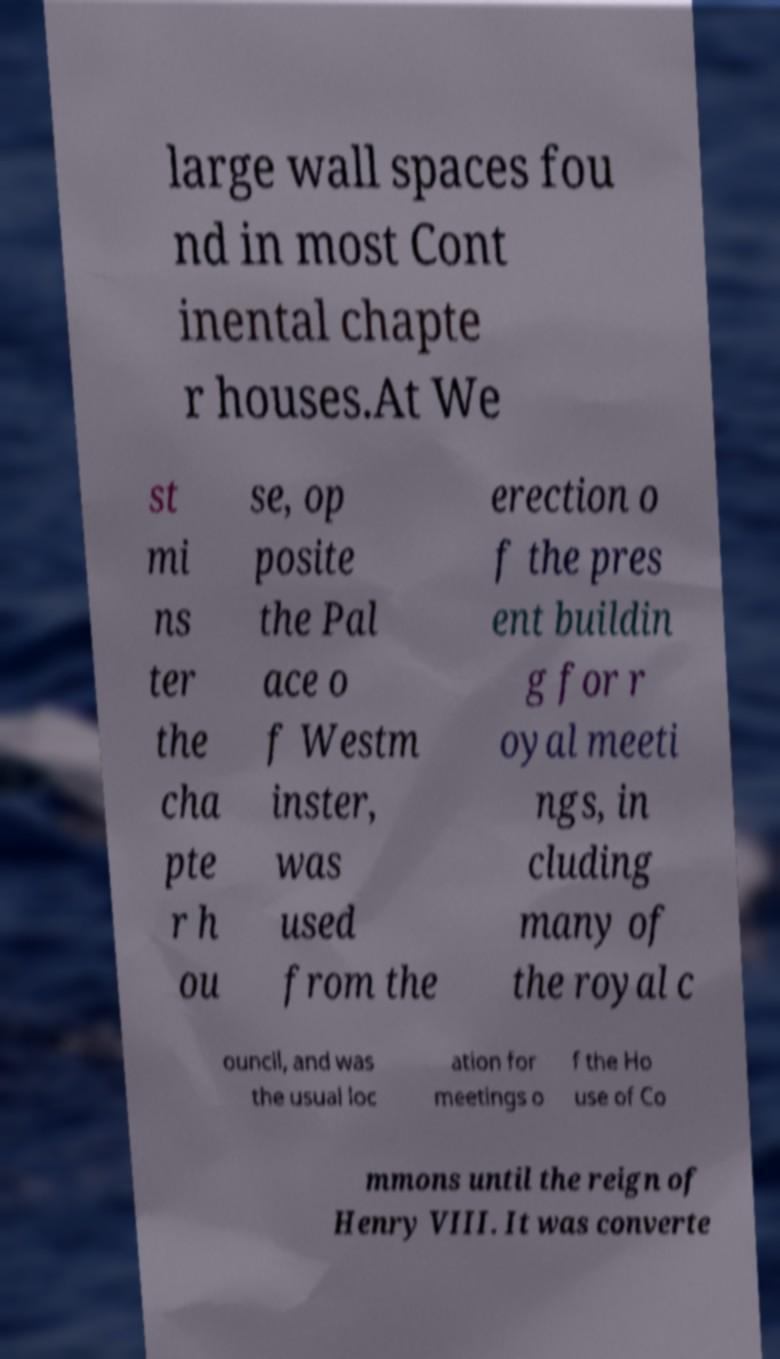There's text embedded in this image that I need extracted. Can you transcribe it verbatim? large wall spaces fou nd in most Cont inental chapte r houses.At We st mi ns ter the cha pte r h ou se, op posite the Pal ace o f Westm inster, was used from the erection o f the pres ent buildin g for r oyal meeti ngs, in cluding many of the royal c ouncil, and was the usual loc ation for meetings o f the Ho use of Co mmons until the reign of Henry VIII. It was converte 